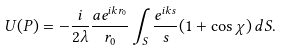<formula> <loc_0><loc_0><loc_500><loc_500>U ( P ) = - { \frac { i } { 2 \lambda } } { \frac { a e ^ { i k r _ { 0 } } } { r _ { 0 } } } \int _ { S } { \frac { e ^ { i k s } } { s } } ( 1 + \cos \chi ) \, d S .</formula> 